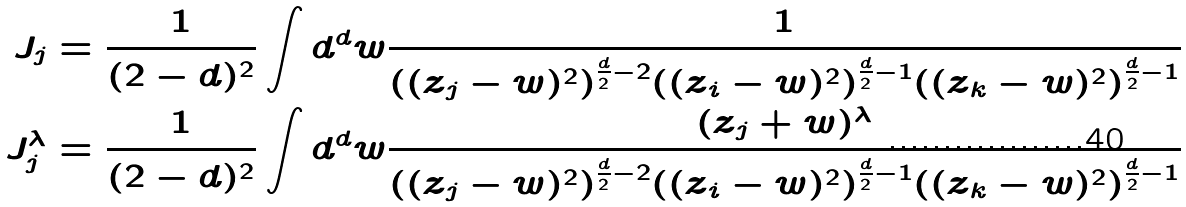<formula> <loc_0><loc_0><loc_500><loc_500>J _ { j } & = \frac { 1 } { ( 2 - d ) ^ { 2 } } \int d ^ { d } w \frac { 1 } { ( ( z _ { j } - w ) ^ { 2 } ) ^ { \frac { d } { 2 } - 2 } ( ( z _ { i } - w ) ^ { 2 } ) ^ { \frac { d } { 2 } - 1 } ( ( z _ { k } - w ) ^ { 2 } ) ^ { \frac { d } { 2 } - 1 } } \\ J _ { j } ^ { \lambda } & = \frac { 1 } { ( 2 - d ) ^ { 2 } } \int d ^ { d } w \frac { ( z _ { j } + w ) ^ { \lambda } } { ( ( z _ { j } - w ) ^ { 2 } ) ^ { \frac { d } { 2 } - 2 } ( ( z _ { i } - w ) ^ { 2 } ) ^ { \frac { d } { 2 } - 1 } ( ( z _ { k } - w ) ^ { 2 } ) ^ { \frac { d } { 2 } - 1 } }</formula> 